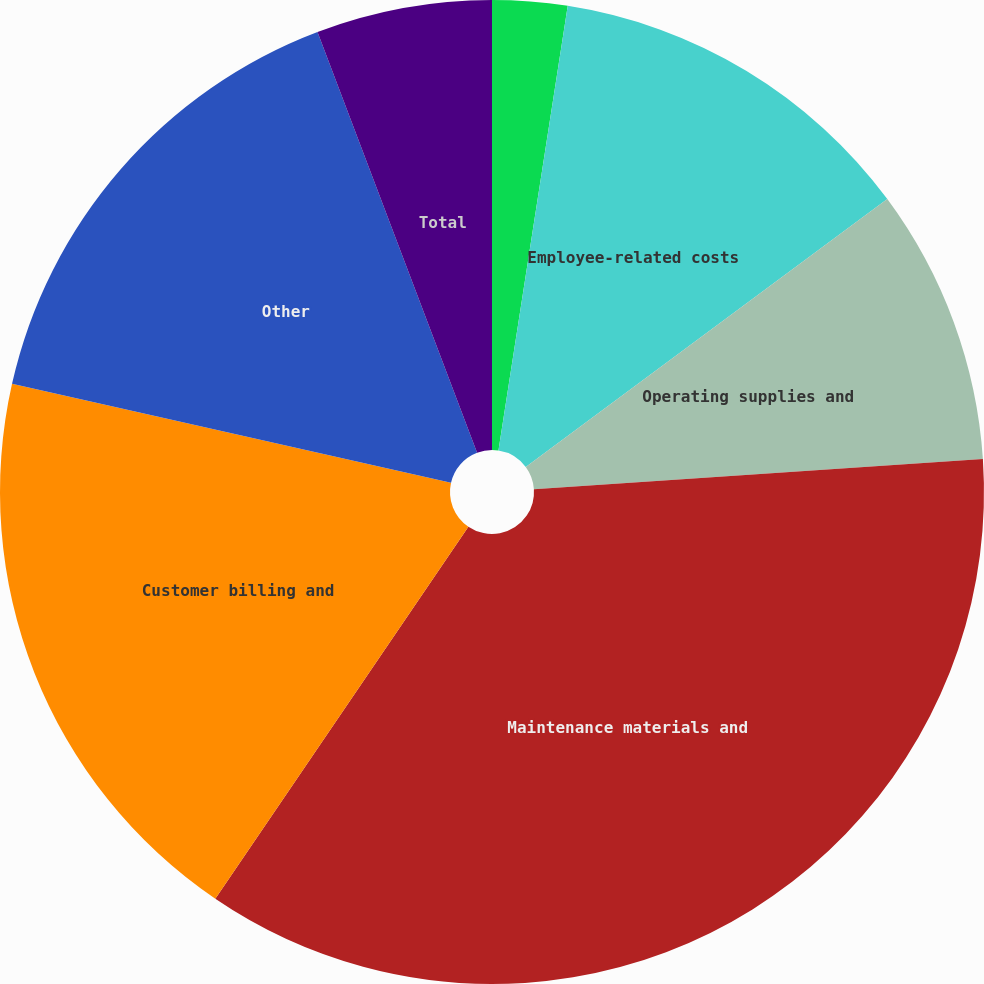Convert chart. <chart><loc_0><loc_0><loc_500><loc_500><pie_chart><fcel>Production costs<fcel>Employee-related costs<fcel>Operating supplies and<fcel>Maintenance materials and<fcel>Customer billing and<fcel>Other<fcel>Total<nl><fcel>2.46%<fcel>12.39%<fcel>9.08%<fcel>35.57%<fcel>19.02%<fcel>15.7%<fcel>5.77%<nl></chart> 